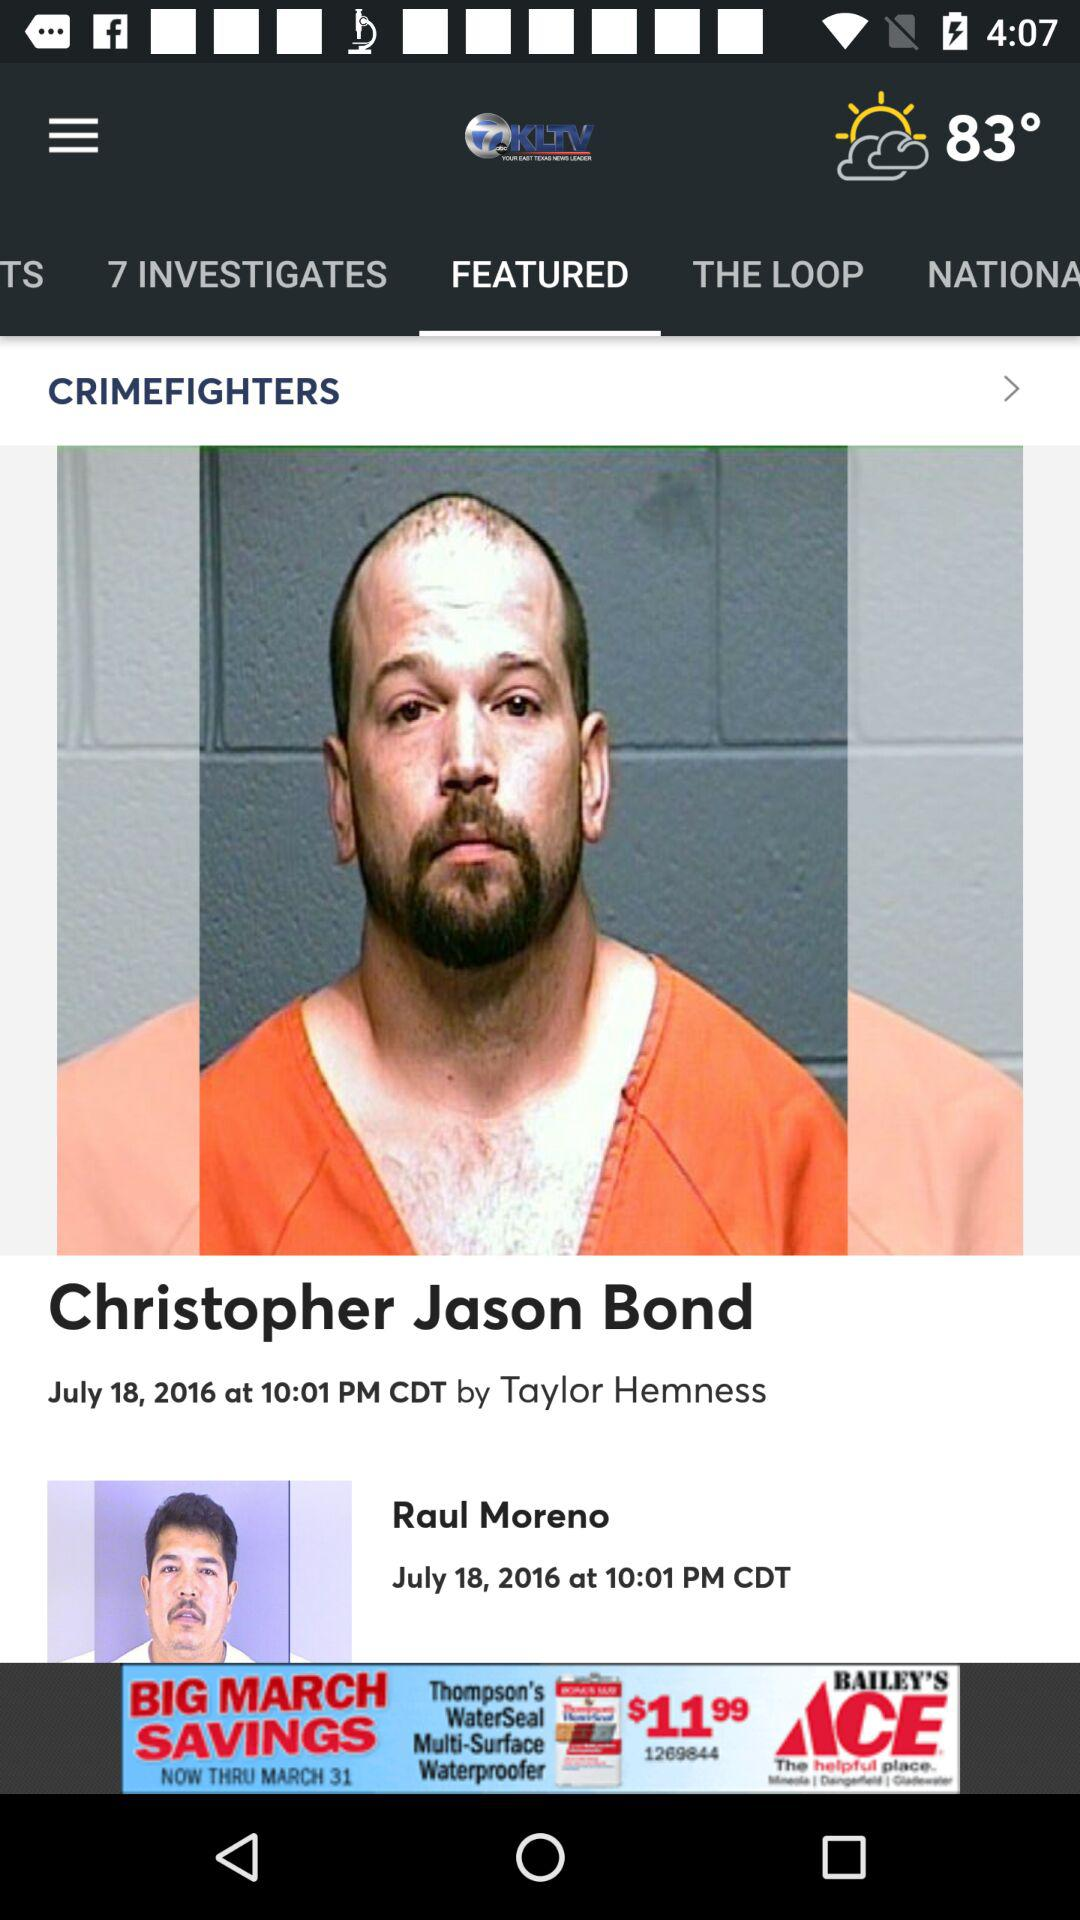When was the news posted? The news was posted on July 18, 2016 at 10:01 PM CDT. 